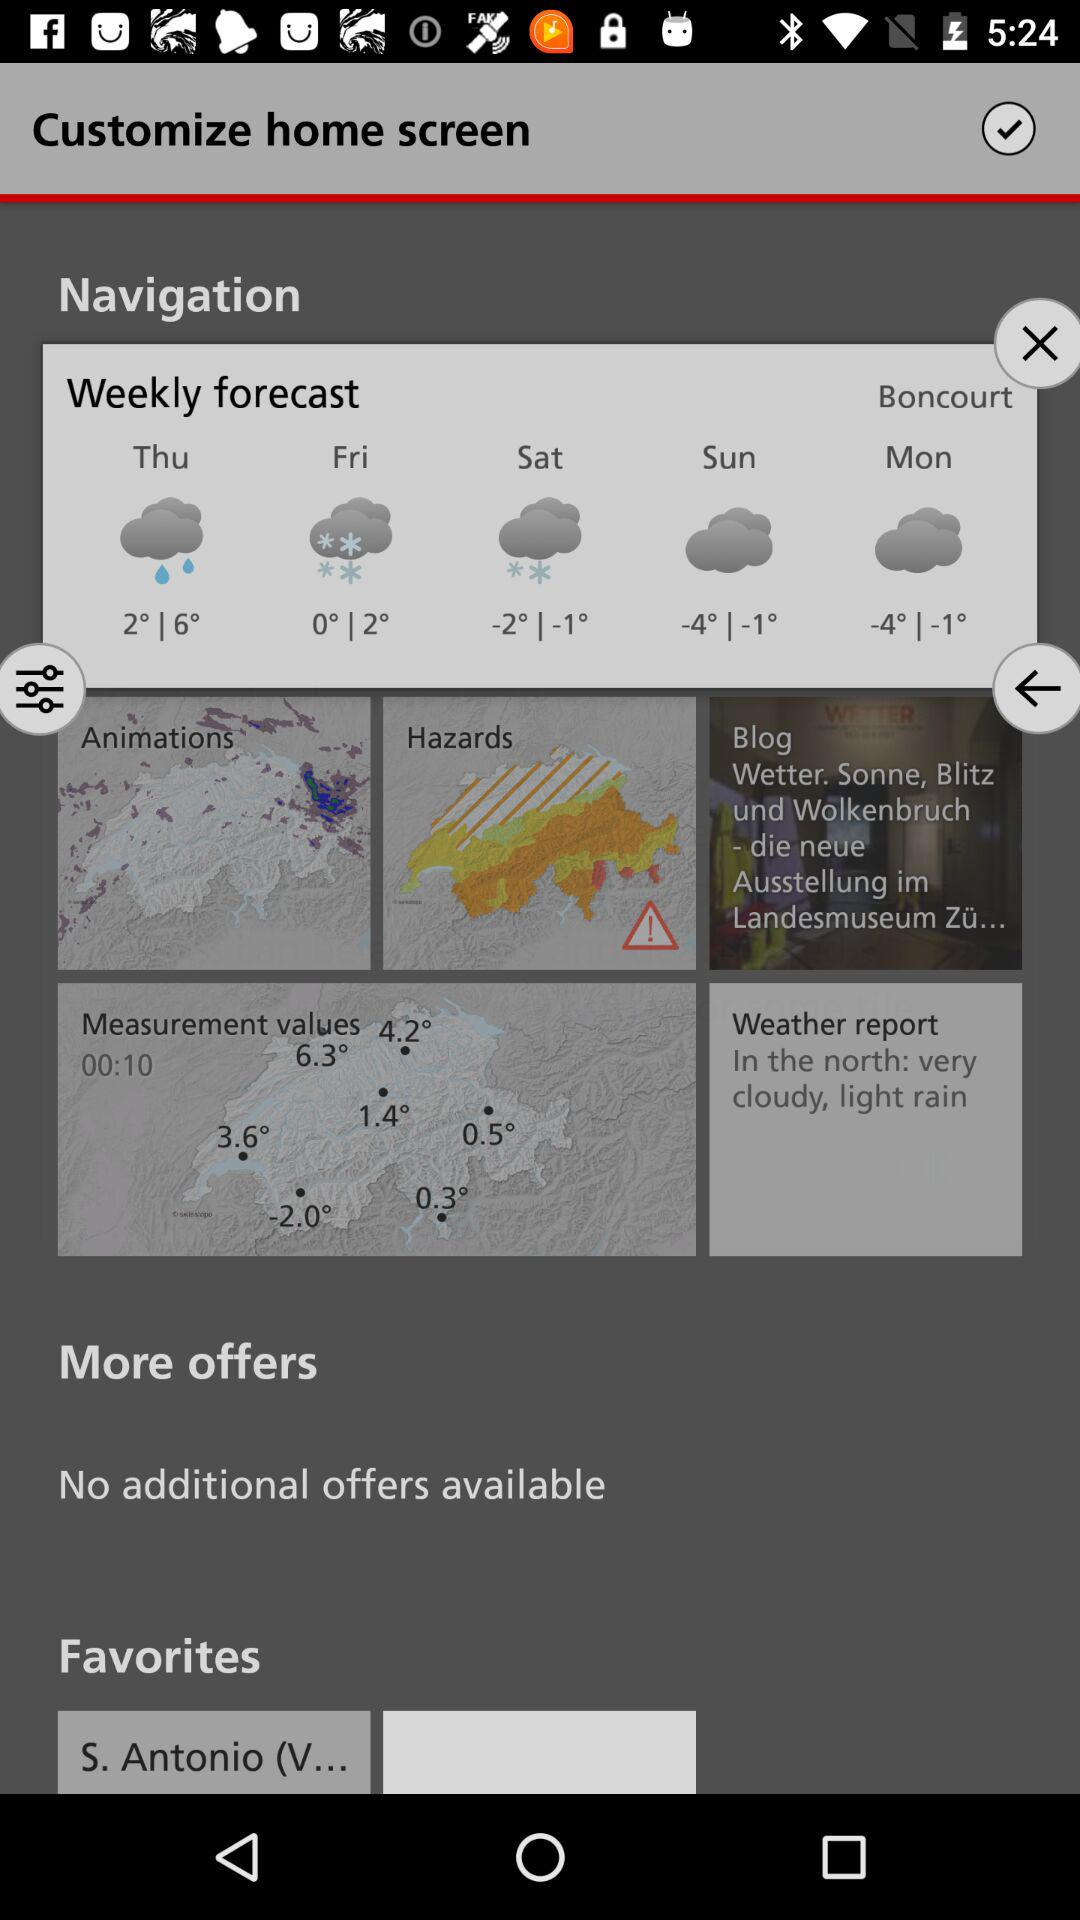What is the temperature on Thursday in the weekly forecast? The temperature on Thursday in the weekly forecast ranges between 2° and 6°. 